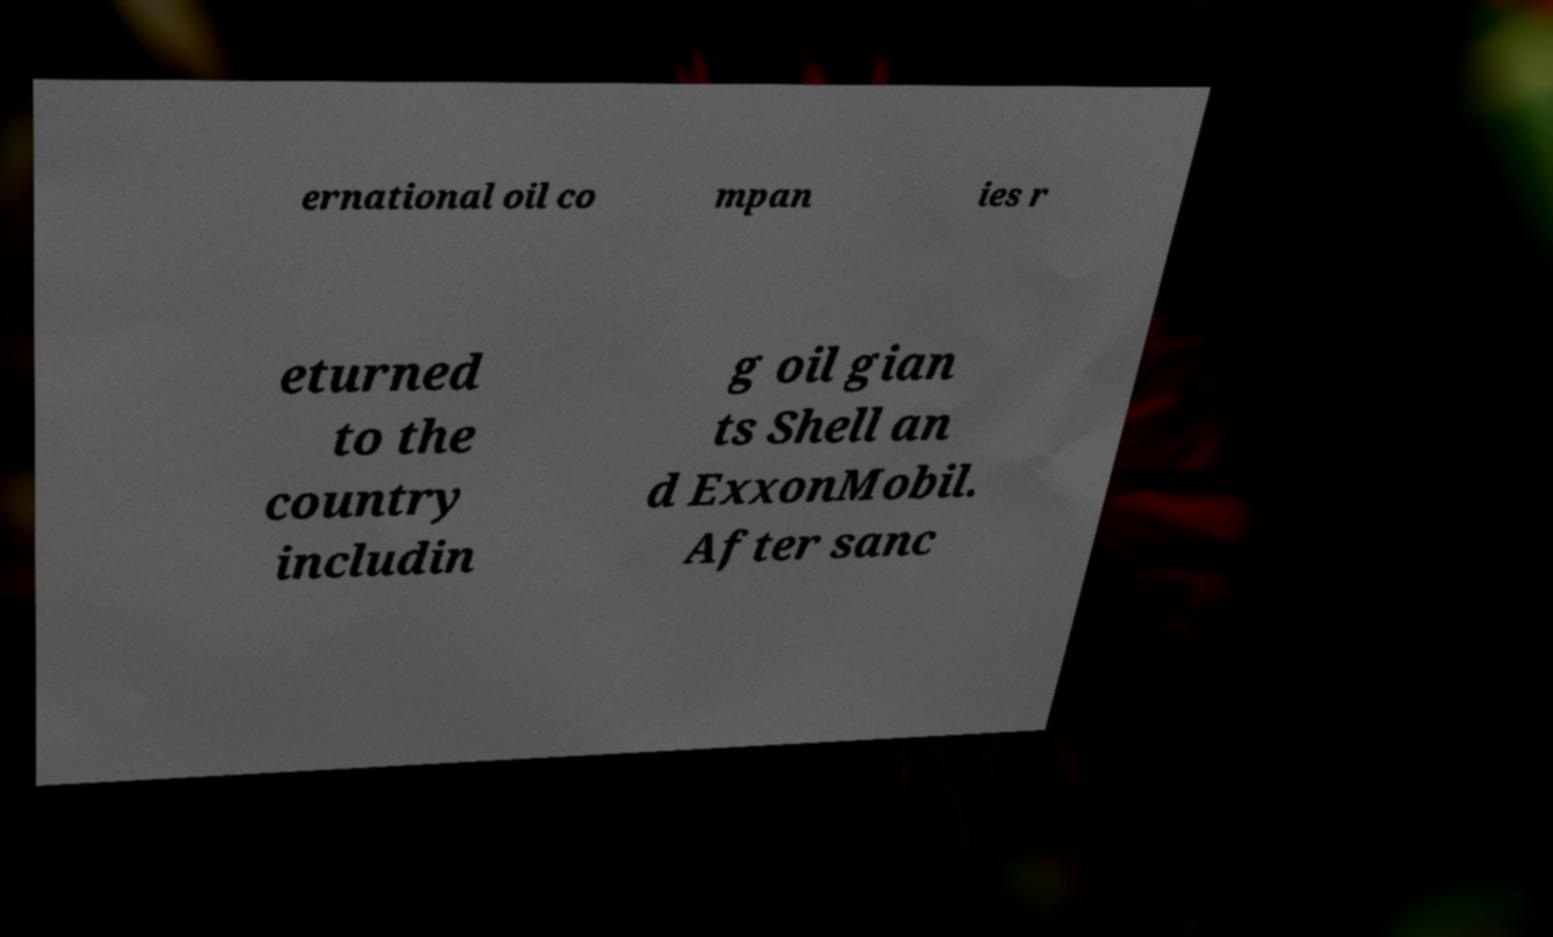For documentation purposes, I need the text within this image transcribed. Could you provide that? ernational oil co mpan ies r eturned to the country includin g oil gian ts Shell an d ExxonMobil. After sanc 